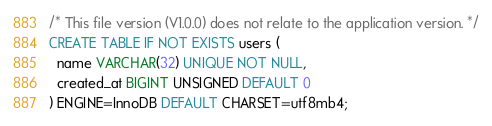Convert code to text. <code><loc_0><loc_0><loc_500><loc_500><_SQL_>/* This file version (V1.0.0) does not relate to the application version. */
CREATE TABLE IF NOT EXISTS users (
  name VARCHAR(32) UNIQUE NOT NULL,
  created_at BIGINT UNSIGNED DEFAULT 0
) ENGINE=InnoDB DEFAULT CHARSET=utf8mb4;
</code> 